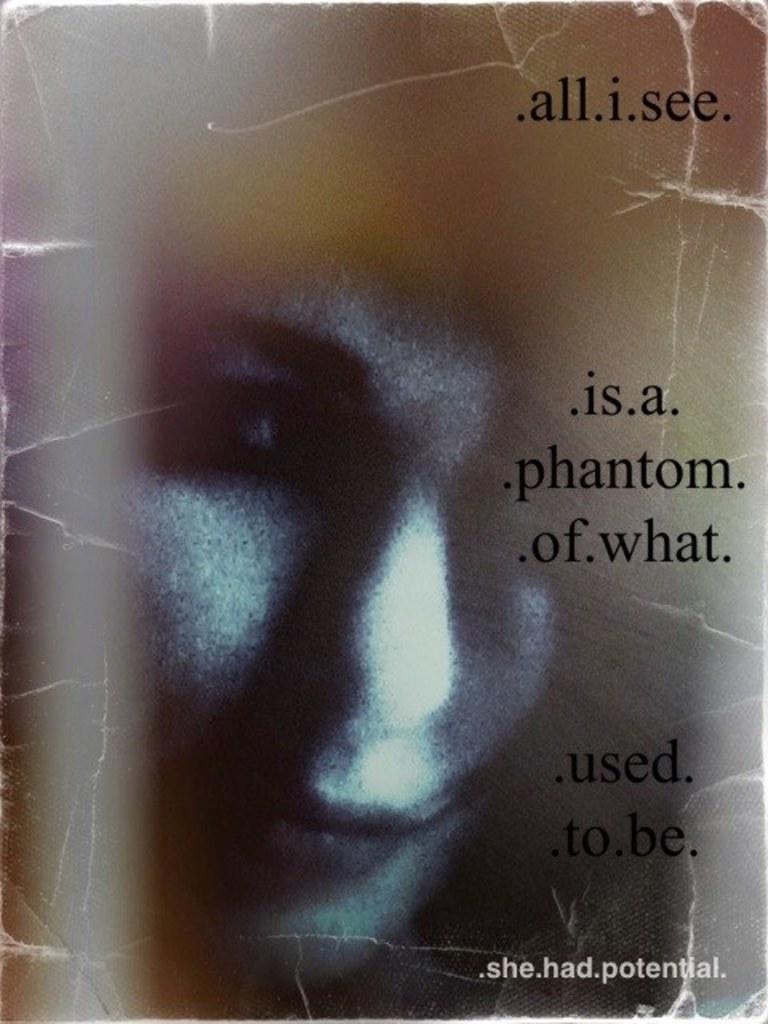Can you describe this image briefly? In this picture we can see a poster,on this poster we can see a woman and some text. 